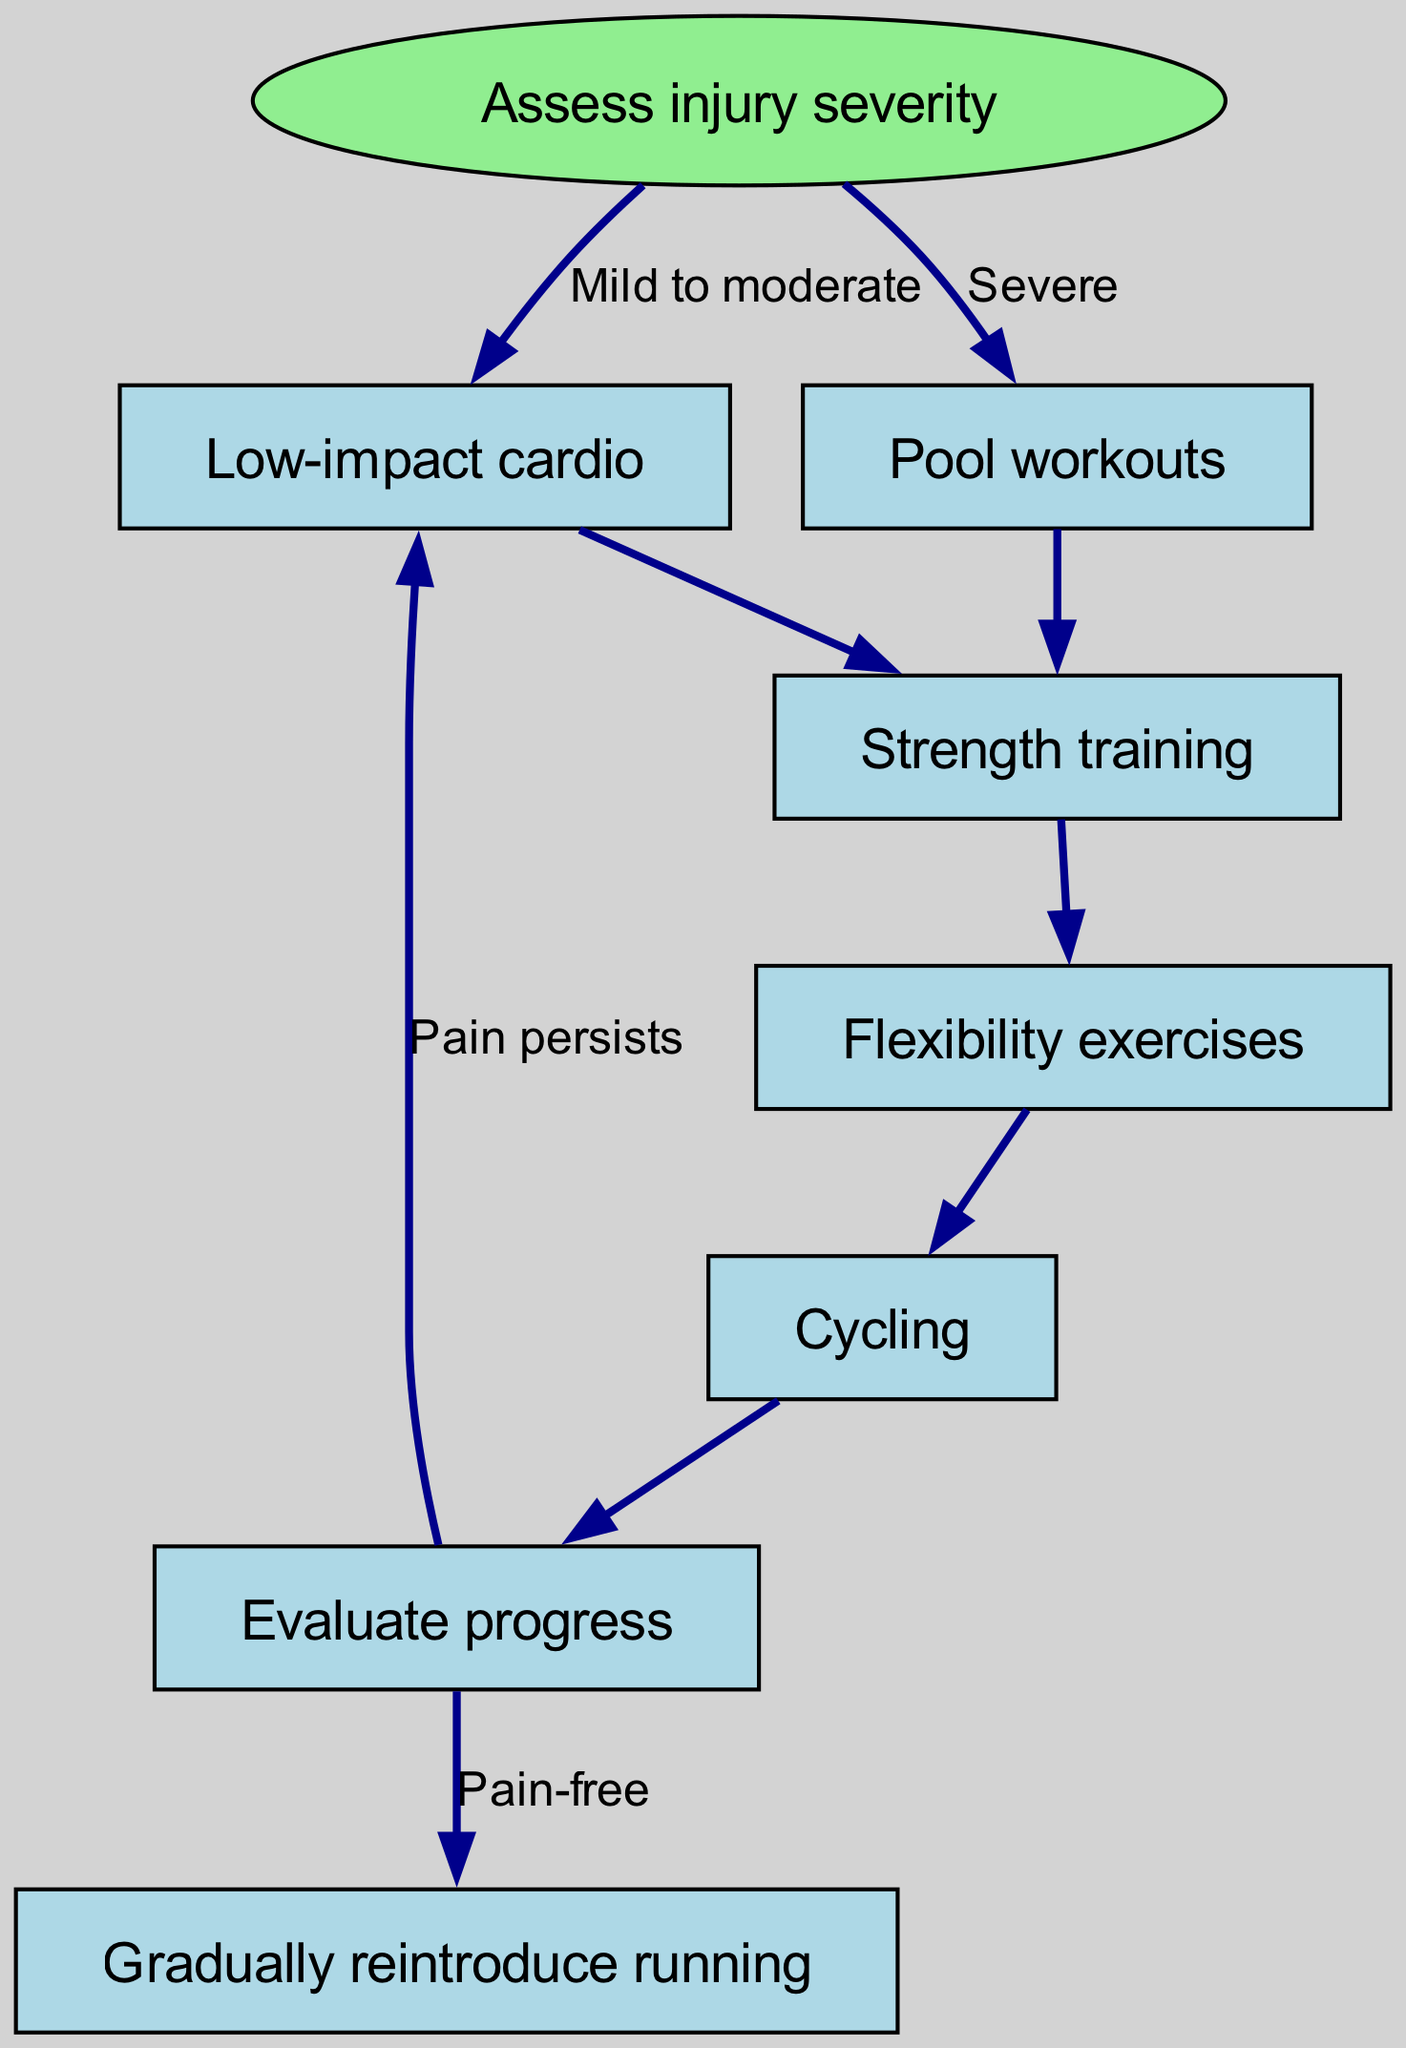What is the starting point of the flow chart? The flow chart starts with the node labeled "Assess injury severity," which is indicated as the entry point of the diagram.
Answer: Assess injury severity How many total nodes are in the diagram? The diagram includes eight nodes, counting both the starting node and the subsequent nodes connected to it.
Answer: Eight What type of workout is suggested for severe injury? For a severe injury, the flow chart suggests "Pool workouts" as the appropriate exercise option.
Answer: Pool workouts What should you do if running causes pain during the evaluation process? If running causes pain during the evaluation process, the flow chart indicates that you should return to "Low-impact cardio," which suggests reconsideration of the exercises.
Answer: Low-impact cardio List the exercise type you would progress to after flexibility exercises. After completing flexibility exercises, the next step in the flow chart is to progress to "Cycling."
Answer: Cycling What is the relationship between "Evaluate progress" and "Gradually reintroduce running"? The relationship is dependent on the condition of being "Pain-free," which is required before moving to "Gradually reintroduce running" from "Evaluate progress."
Answer: Pain-free After "Cycling," what is the next action indicated by the flow chart? After "Cycling," the flow chart directs to "Evaluate progress" as the subsequent step in the plan.
Answer: Evaluate progress Which workout type directly follows "Low-impact cardio"? The workout type that directly follows "Low-impact cardio" in the sequence is "Strength training."
Answer: Strength training 